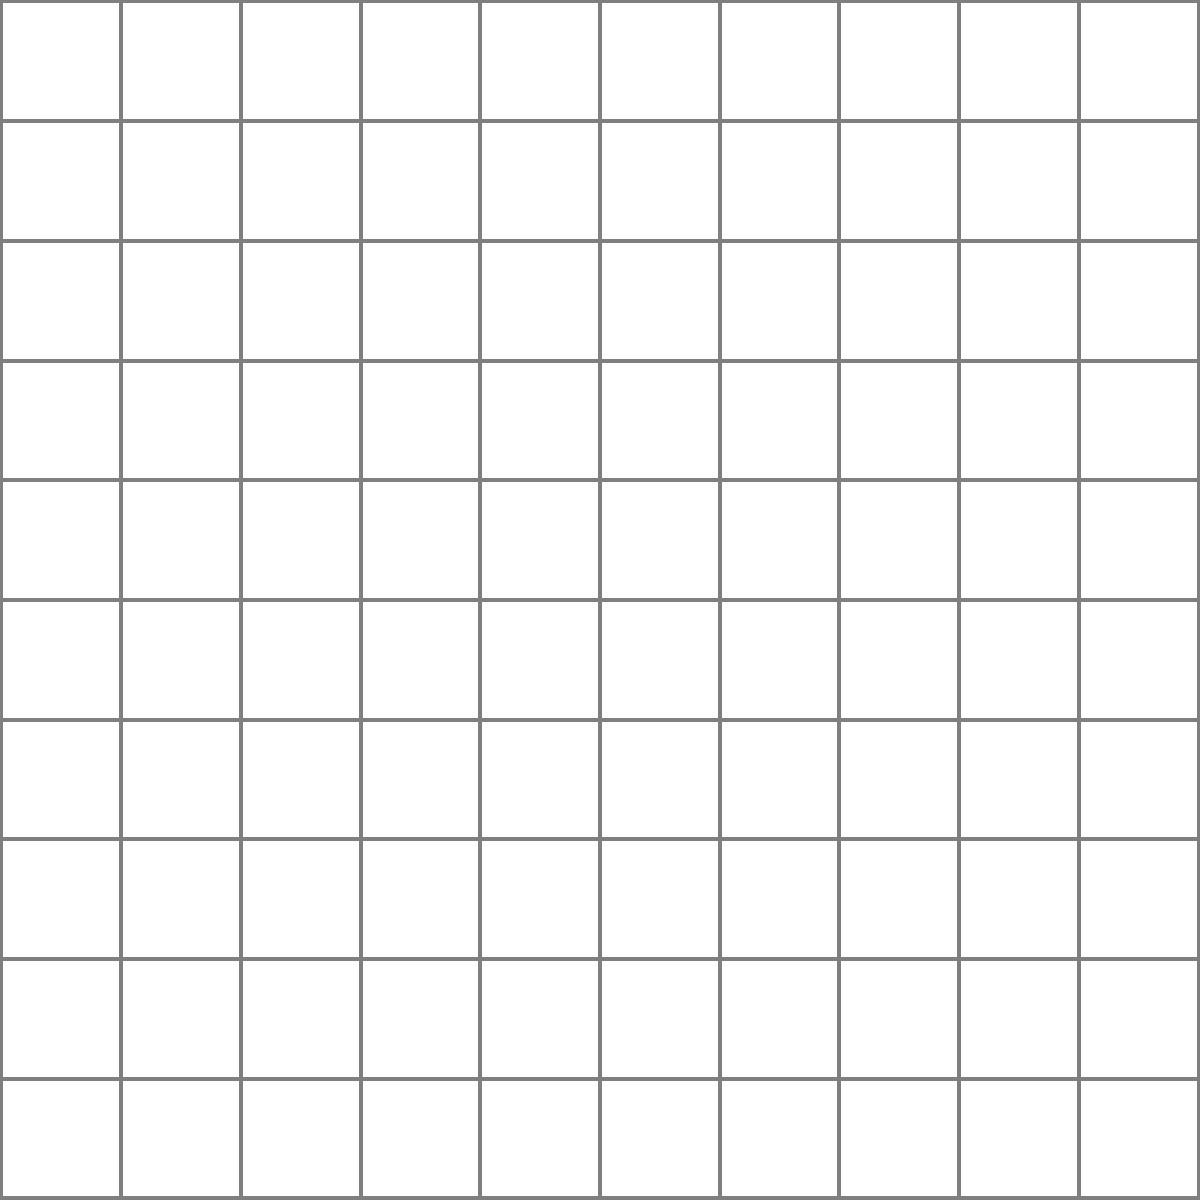Using the simplified map of Marlborough with a 10x10 grid overlay, where each grid cell represents 1 square kilometer, estimate the area of the city in square kilometers. Round your answer to the nearest whole number. To estimate the area of Marlborough using the grid method, we'll follow these steps:

1. Count the number of full grid cells within the city boundaries:
   There are approximately 30 full cells.

2. Count the number of partial grid cells that are more than half filled:
   There are about 14 cells that are more than half filled.

3. Add the full cells and the partial cells:
   $30 + 14 = 44$

4. Since each grid cell represents 1 square kilometer, the estimated area is 44 square kilometers.

5. The question asks to round to the nearest whole number, but 44 is already a whole number, so no further rounding is necessary.

This method provides a reasonable estimate of the city's area based on the given map and grid overlay.
Answer: 44 km² 